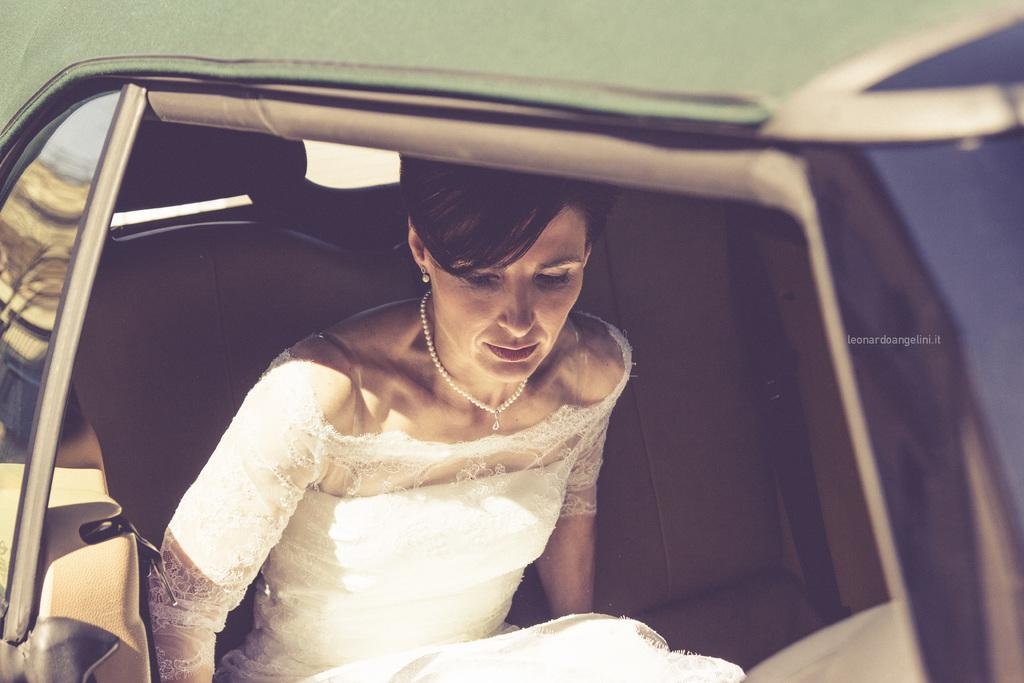Who is present in the image? There is a woman in the image. What is the woman wearing? The woman is wearing a white dress. Where is the woman located in the image? The woman is sitting in the seat of a car. What type of knot can be seen tied around the lamp in the image? There is no lamp or knot present in the image. 